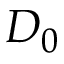<formula> <loc_0><loc_0><loc_500><loc_500>D _ { 0 }</formula> 